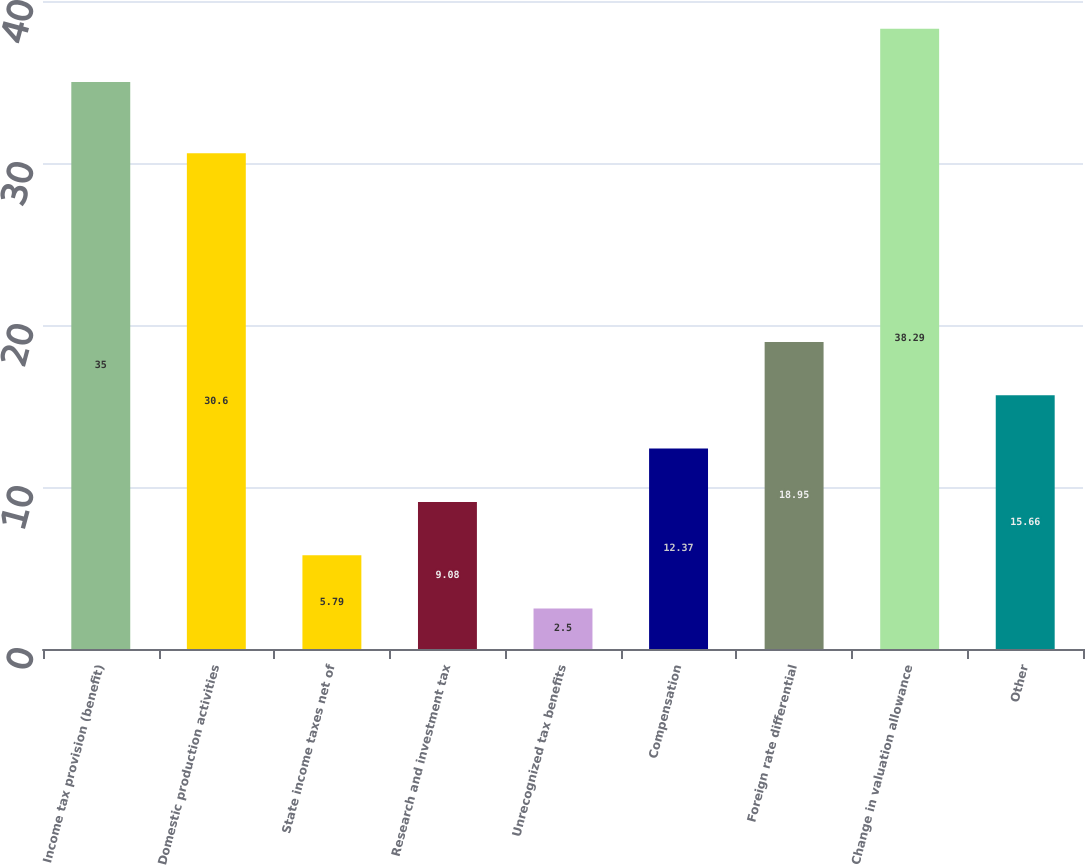<chart> <loc_0><loc_0><loc_500><loc_500><bar_chart><fcel>Income tax provision (benefit)<fcel>Domestic production activities<fcel>State income taxes net of<fcel>Research and investment tax<fcel>Unrecognized tax benefits<fcel>Compensation<fcel>Foreign rate differential<fcel>Change in valuation allowance<fcel>Other<nl><fcel>35<fcel>30.6<fcel>5.79<fcel>9.08<fcel>2.5<fcel>12.37<fcel>18.95<fcel>38.29<fcel>15.66<nl></chart> 